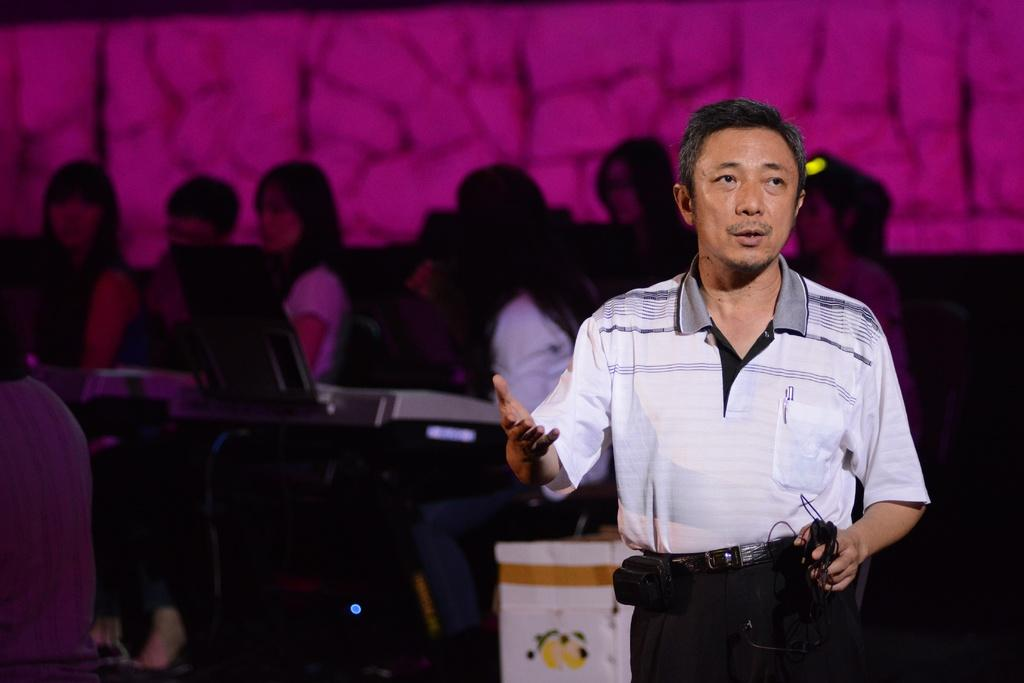What is the main subject of the image? There is a man standing in the image. Can you describe the background of the image? There are people sitting on chairs in the background of the image. What are the people sitting on chairs doing? The people sitting on chairs are in front of musical instruments. What type of cannon is being fired in the image? There is no cannon present in the image; it features a man standing and people sitting on chairs with musical instruments. Can you describe the nose of the man in the image? The provided facts do not mention the man's nose, so it cannot be described. 